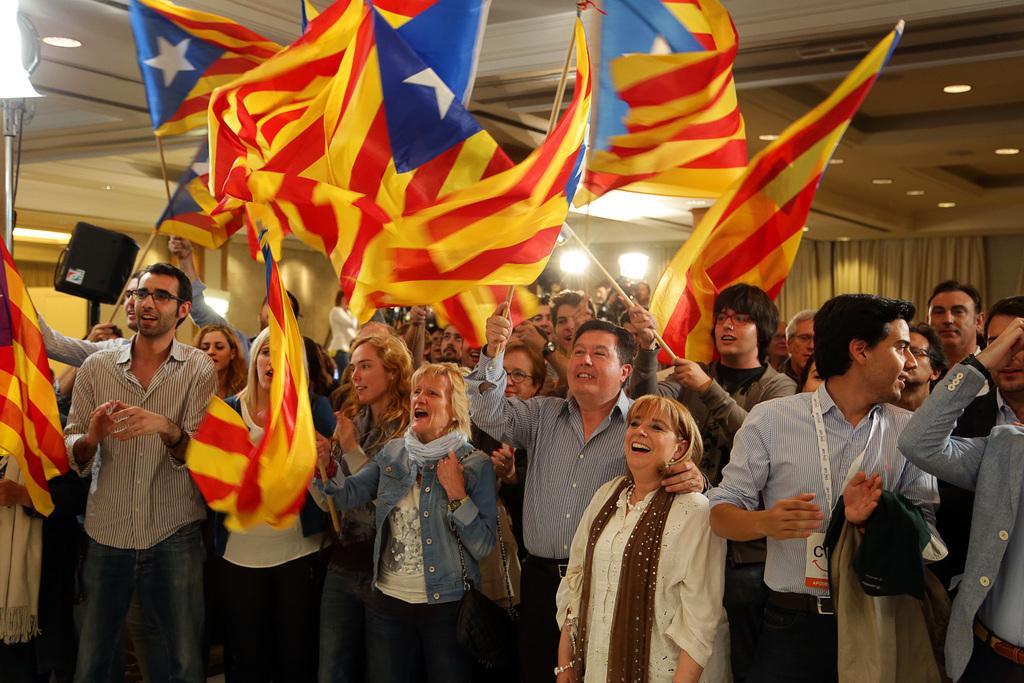How would you summarize this image in a sentence or two? In this image I can see group of people standing and holding few flags and the flags are in blue, white, yellow and red color. In the background I can see few lights. 